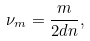Convert formula to latex. <formula><loc_0><loc_0><loc_500><loc_500>\nu _ { m } = \frac { m } { 2 d n } ,</formula> 